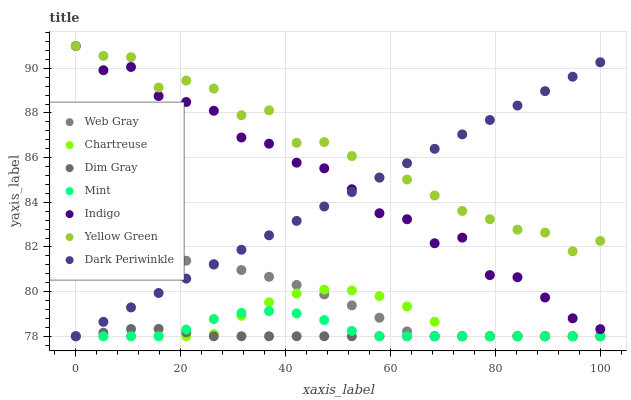Does Dim Gray have the minimum area under the curve?
Answer yes or no. Yes. Does Yellow Green have the maximum area under the curve?
Answer yes or no. Yes. Does Indigo have the minimum area under the curve?
Answer yes or no. No. Does Indigo have the maximum area under the curve?
Answer yes or no. No. Is Dark Periwinkle the smoothest?
Answer yes or no. Yes. Is Indigo the roughest?
Answer yes or no. Yes. Is Yellow Green the smoothest?
Answer yes or no. No. Is Yellow Green the roughest?
Answer yes or no. No. Does Web Gray have the lowest value?
Answer yes or no. Yes. Does Indigo have the lowest value?
Answer yes or no. No. Does Yellow Green have the highest value?
Answer yes or no. Yes. Does Chartreuse have the highest value?
Answer yes or no. No. Is Dim Gray less than Yellow Green?
Answer yes or no. Yes. Is Indigo greater than Mint?
Answer yes or no. Yes. Does Dim Gray intersect Web Gray?
Answer yes or no. Yes. Is Dim Gray less than Web Gray?
Answer yes or no. No. Is Dim Gray greater than Web Gray?
Answer yes or no. No. Does Dim Gray intersect Yellow Green?
Answer yes or no. No. 